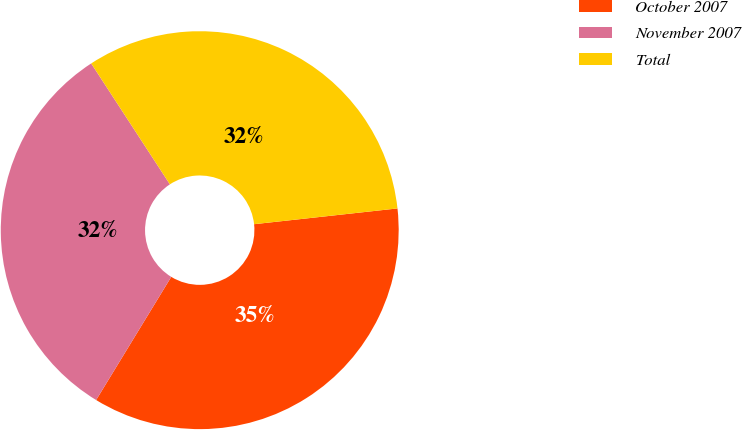Convert chart to OTSL. <chart><loc_0><loc_0><loc_500><loc_500><pie_chart><fcel>October 2007<fcel>November 2007<fcel>Total<nl><fcel>35.46%<fcel>32.1%<fcel>32.44%<nl></chart> 